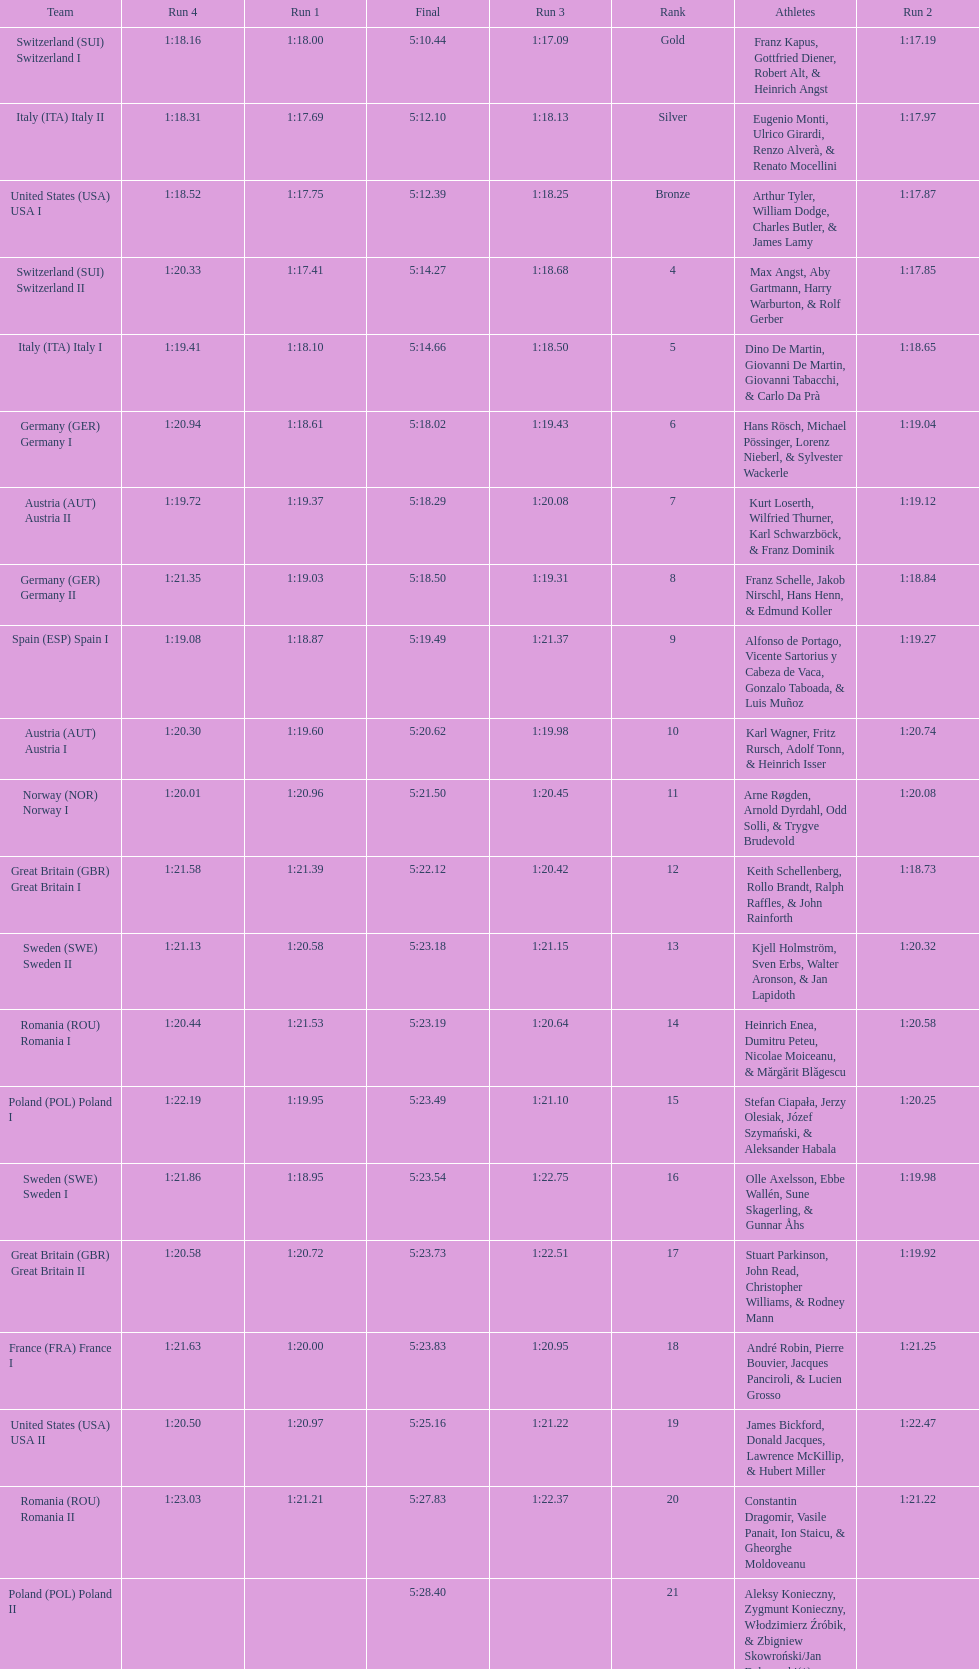Name a country that had 4 consecutive runs under 1:19. Switzerland. 